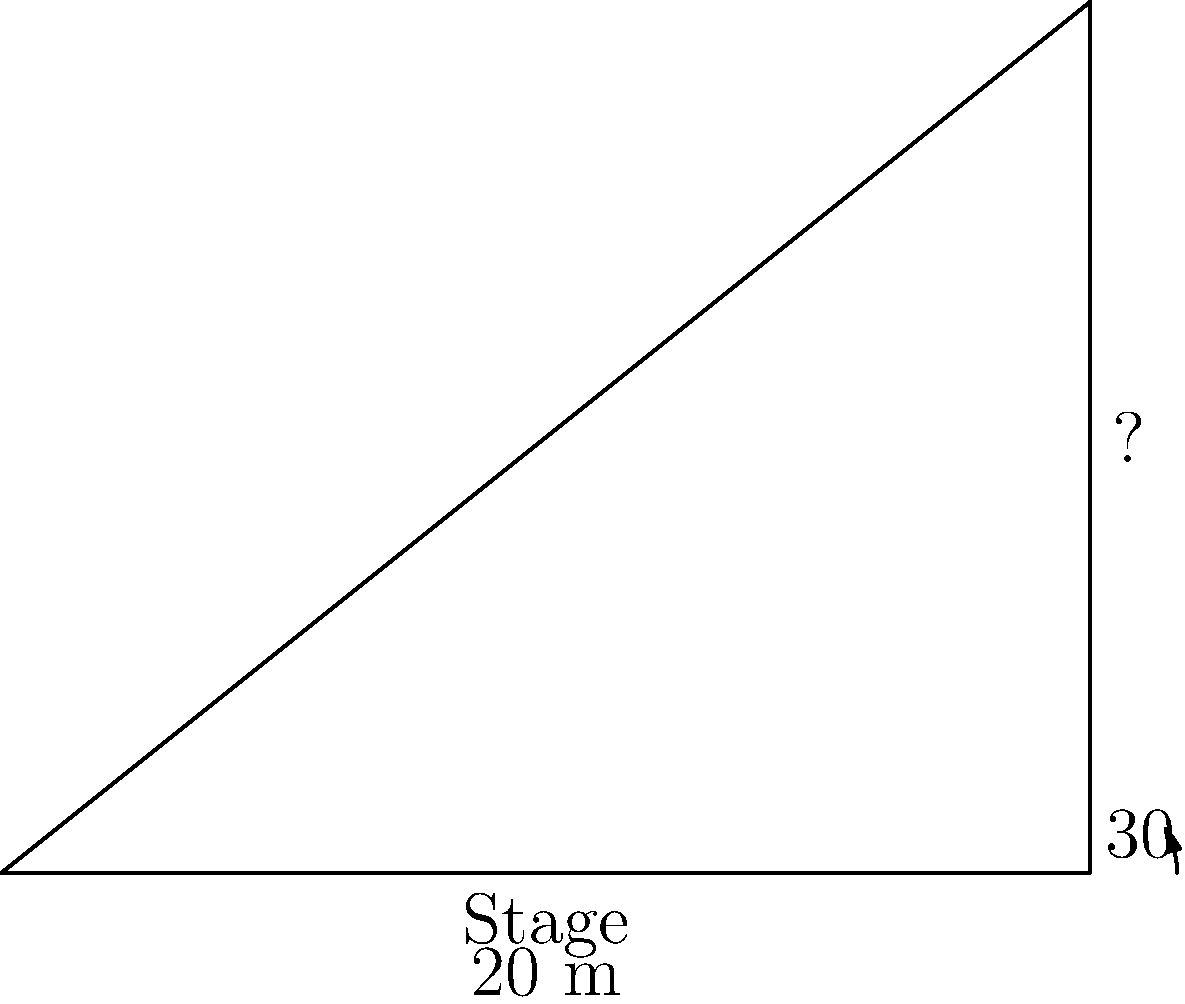At a jazz concert featuring Oscar Peterson, you're seated 20 meters from the stage. Looking up at the ceiling, you notice that the angle of elevation from your eye level to the top of the stage is 30°. Assuming your eye level is at the same height as the stage, what is the height of the concert hall's ceiling? Let's approach this step-by-step using trigonometry:

1) We can model this scenario as a right-angled triangle, where:
   - The base of the triangle is the distance from you to the stage (20 m)
   - The height of the triangle is the height of the ceiling
   - The angle between the base and the hypotenuse is 30°

2) In a right-angled triangle, we can use the tangent function to find the height:

   $\tan(\theta) = \frac{\text{opposite}}{\text{adjacent}}$

3) In this case:
   $\tan(30°) = \frac{\text{height}}{20}$

4) We know that $\tan(30°) = \frac{1}{\sqrt{3}}$, so we can write:

   $\frac{1}{\sqrt{3}} = \frac{\text{height}}{20}$

5) Cross-multiply:

   $20 = \text{height} \cdot \sqrt{3}$

6) Solve for height:

   $\text{height} = \frac{20}{\sqrt{3}}$

7) Simplify:
   
   $\text{height} = 20 \cdot \frac{\sqrt{3}}{3} \approx 11.55$ meters

Therefore, the height of the concert hall's ceiling is approximately 11.55 meters.
Answer: $\frac{20\sqrt{3}}{3}$ m or approximately 11.55 m 